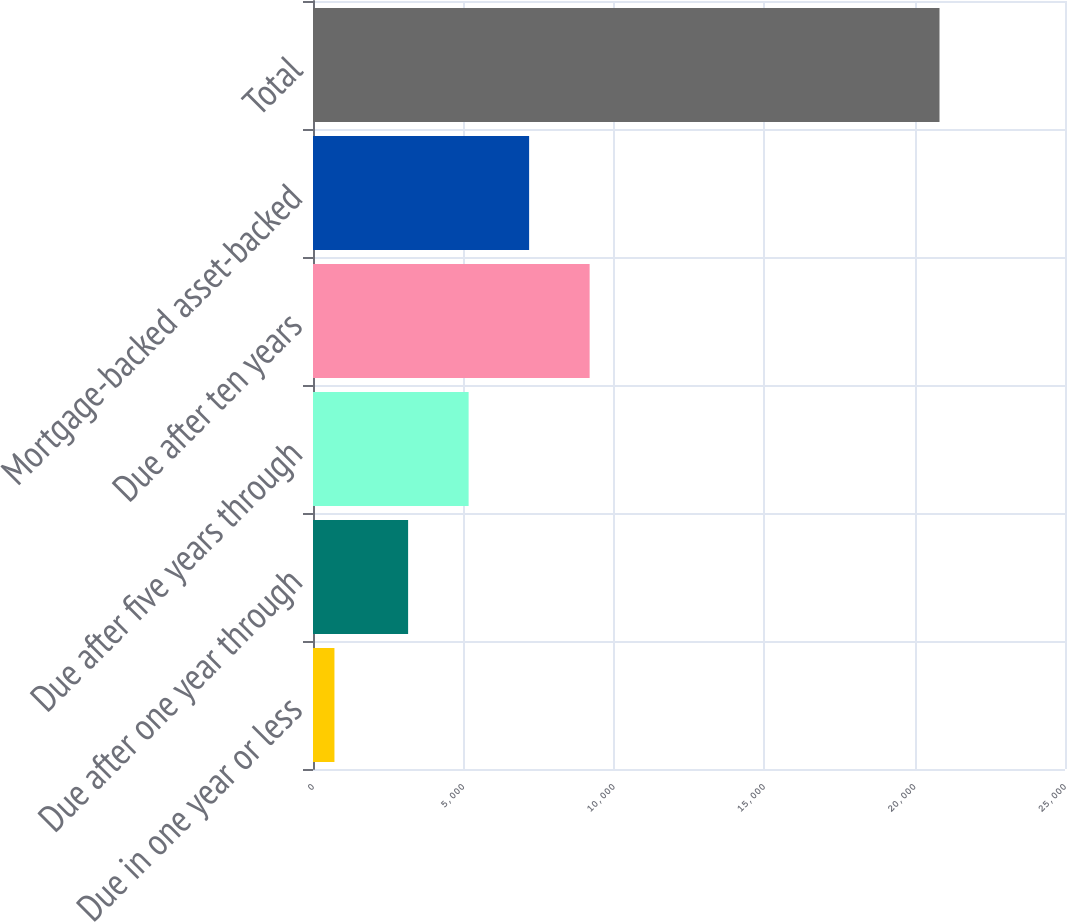Convert chart. <chart><loc_0><loc_0><loc_500><loc_500><bar_chart><fcel>Due in one year or less<fcel>Due after one year through<fcel>Due after five years through<fcel>Due after ten years<fcel>Mortgage-backed asset-backed<fcel>Total<nl><fcel>713<fcel>3162<fcel>5173.5<fcel>9196.5<fcel>7185<fcel>20828<nl></chart> 